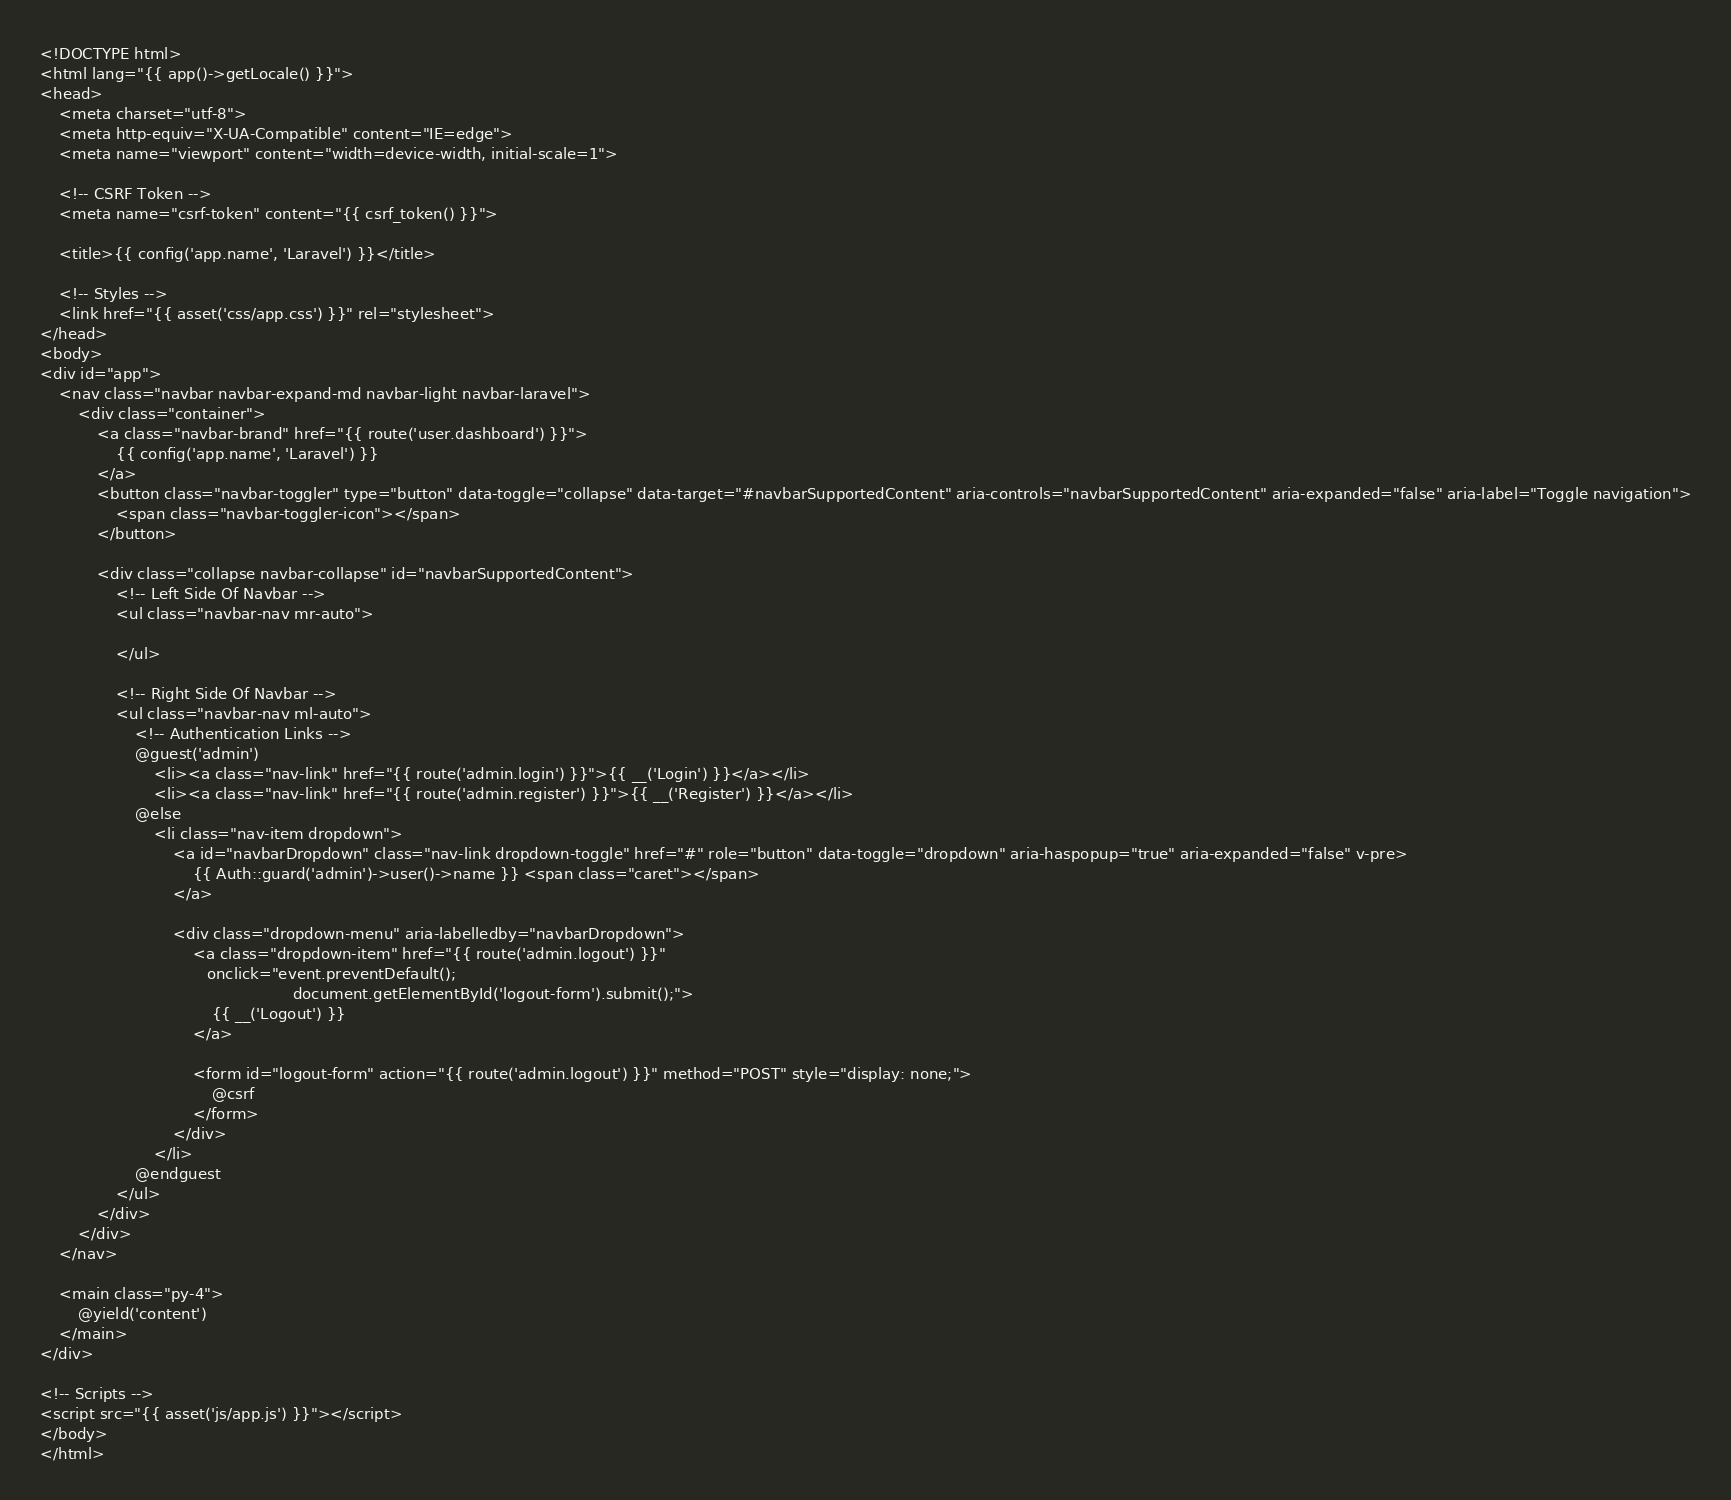<code> <loc_0><loc_0><loc_500><loc_500><_PHP_><!DOCTYPE html>
<html lang="{{ app()->getLocale() }}">
<head>
    <meta charset="utf-8">
    <meta http-equiv="X-UA-Compatible" content="IE=edge">
    <meta name="viewport" content="width=device-width, initial-scale=1">

    <!-- CSRF Token -->
    <meta name="csrf-token" content="{{ csrf_token() }}">

    <title>{{ config('app.name', 'Laravel') }}</title>

    <!-- Styles -->
    <link href="{{ asset('css/app.css') }}" rel="stylesheet">
</head>
<body>
<div id="app">
    <nav class="navbar navbar-expand-md navbar-light navbar-laravel">
        <div class="container">
            <a class="navbar-brand" href="{{ route('user.dashboard') }}">
                {{ config('app.name', 'Laravel') }}
            </a>
            <button class="navbar-toggler" type="button" data-toggle="collapse" data-target="#navbarSupportedContent" aria-controls="navbarSupportedContent" aria-expanded="false" aria-label="Toggle navigation">
                <span class="navbar-toggler-icon"></span>
            </button>

            <div class="collapse navbar-collapse" id="navbarSupportedContent">
                <!-- Left Side Of Navbar -->
                <ul class="navbar-nav mr-auto">

                </ul>

                <!-- Right Side Of Navbar -->
                <ul class="navbar-nav ml-auto">
                    <!-- Authentication Links -->
                    @guest('admin')
                        <li><a class="nav-link" href="{{ route('admin.login') }}">{{ __('Login') }}</a></li>
                        <li><a class="nav-link" href="{{ route('admin.register') }}">{{ __('Register') }}</a></li>
                    @else
                        <li class="nav-item dropdown">
                            <a id="navbarDropdown" class="nav-link dropdown-toggle" href="#" role="button" data-toggle="dropdown" aria-haspopup="true" aria-expanded="false" v-pre>
                                {{ Auth::guard('admin')->user()->name }} <span class="caret"></span>
                            </a>

                            <div class="dropdown-menu" aria-labelledby="navbarDropdown">
                                <a class="dropdown-item" href="{{ route('admin.logout') }}"
                                   onclick="event.preventDefault();
                                                     document.getElementById('logout-form').submit();">
                                    {{ __('Logout') }}
                                </a>

                                <form id="logout-form" action="{{ route('admin.logout') }}" method="POST" style="display: none;">
                                    @csrf
                                </form>
                            </div>
                        </li>
                    @endguest
                </ul>
            </div>
        </div>
    </nav>

    <main class="py-4">
        @yield('content')
    </main>
</div>

<!-- Scripts -->
<script src="{{ asset('js/app.js') }}"></script>
</body>
</html>
</code> 